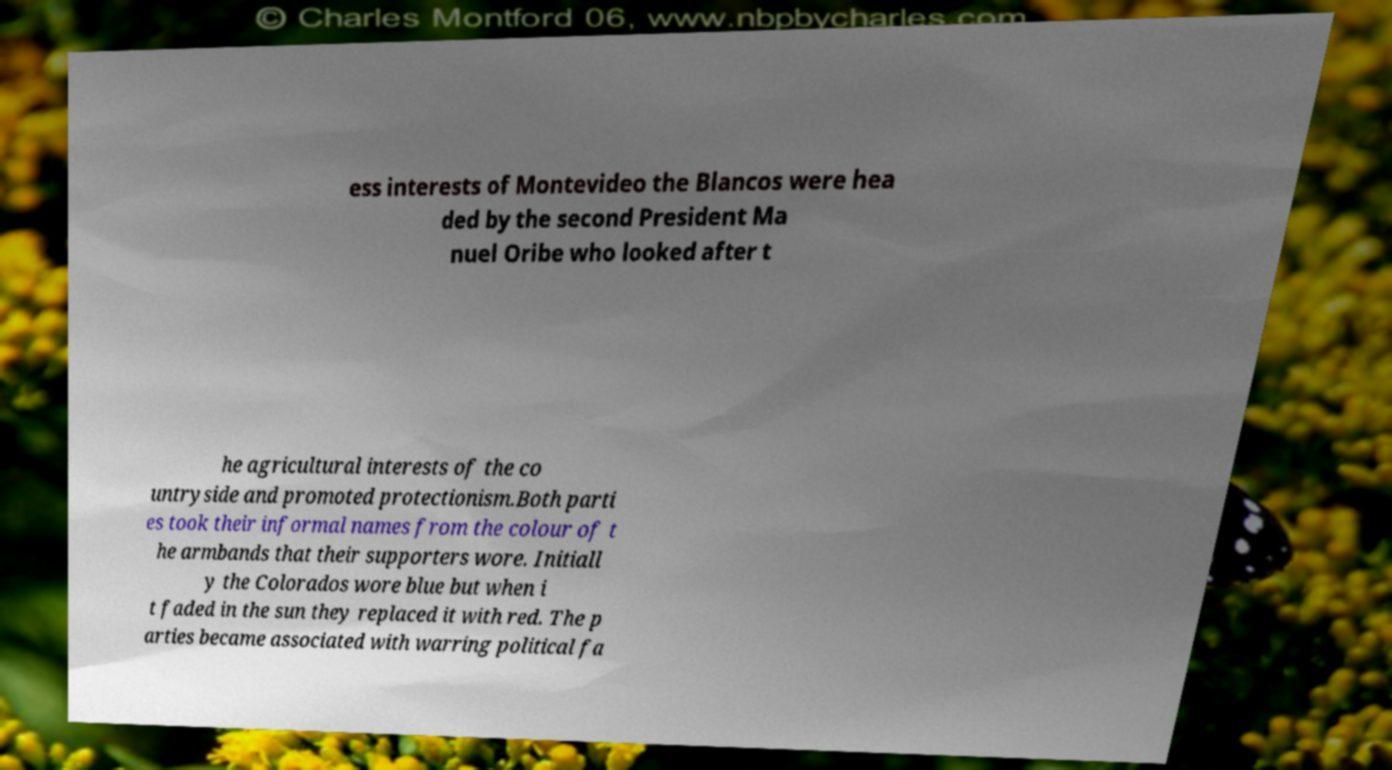Please read and relay the text visible in this image. What does it say? ess interests of Montevideo the Blancos were hea ded by the second President Ma nuel Oribe who looked after t he agricultural interests of the co untryside and promoted protectionism.Both parti es took their informal names from the colour of t he armbands that their supporters wore. Initiall y the Colorados wore blue but when i t faded in the sun they replaced it with red. The p arties became associated with warring political fa 